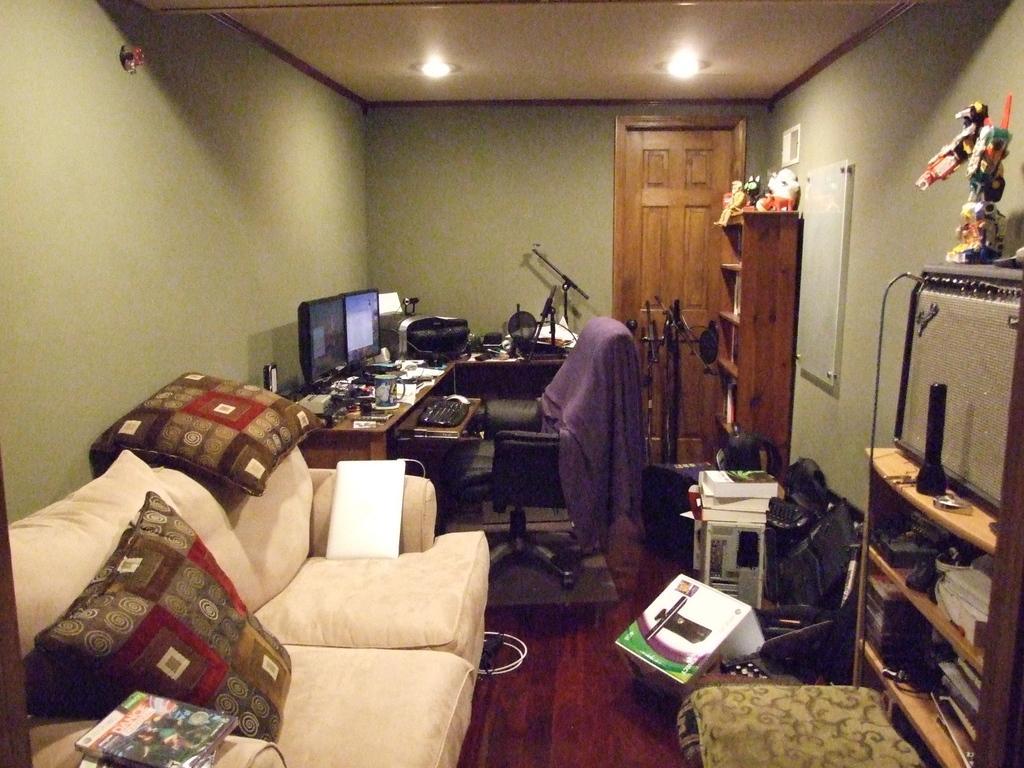Could you give a brief overview of what you see in this image? In this picture we can see a room which consists of a sofa there are two pillows on the sofa and we can see books hear on the left side of the image we can see two monitors and a keyboard here there is a Computer table here we can see a cup on the table and right side you can a door and wooden rack and we can see a robot toy on the ceiling we can see lamps here. 